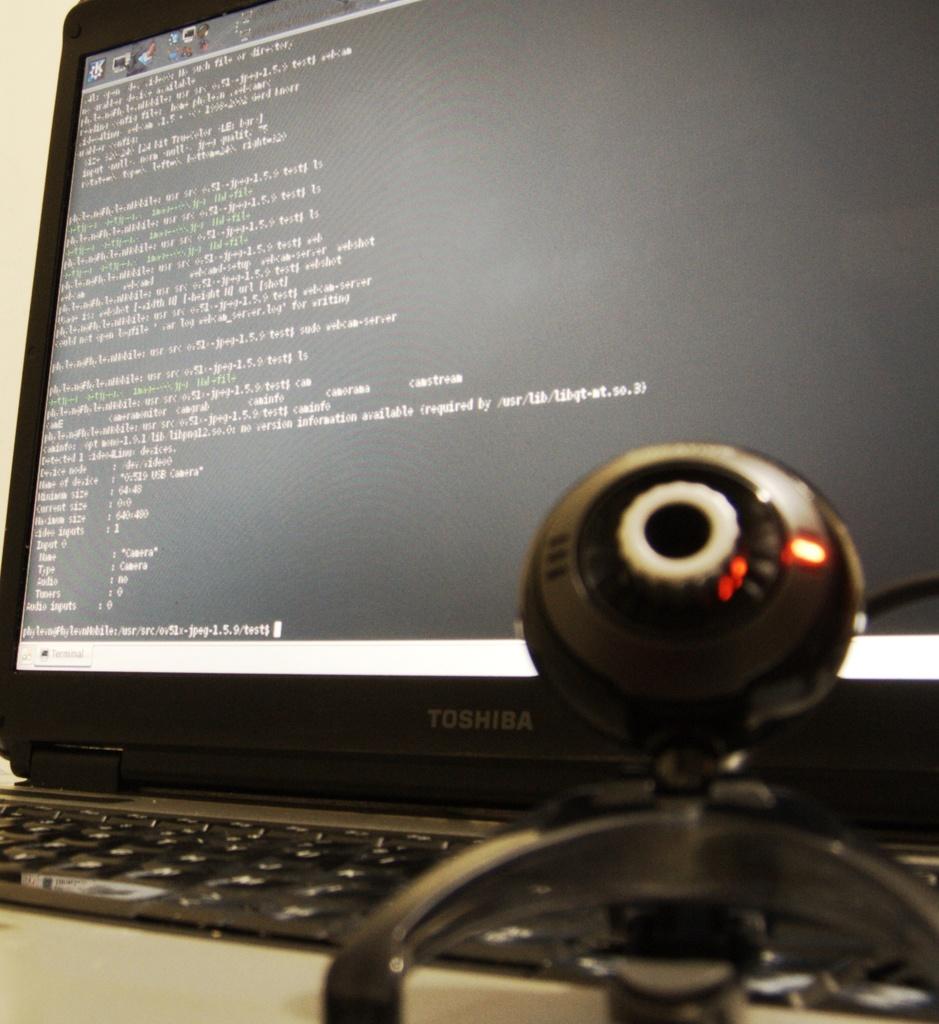What brand of monitor do they have?
Provide a succinct answer. Toshiba. This is a system web camera?
Your response must be concise. Answering does not require reading text in the image. 